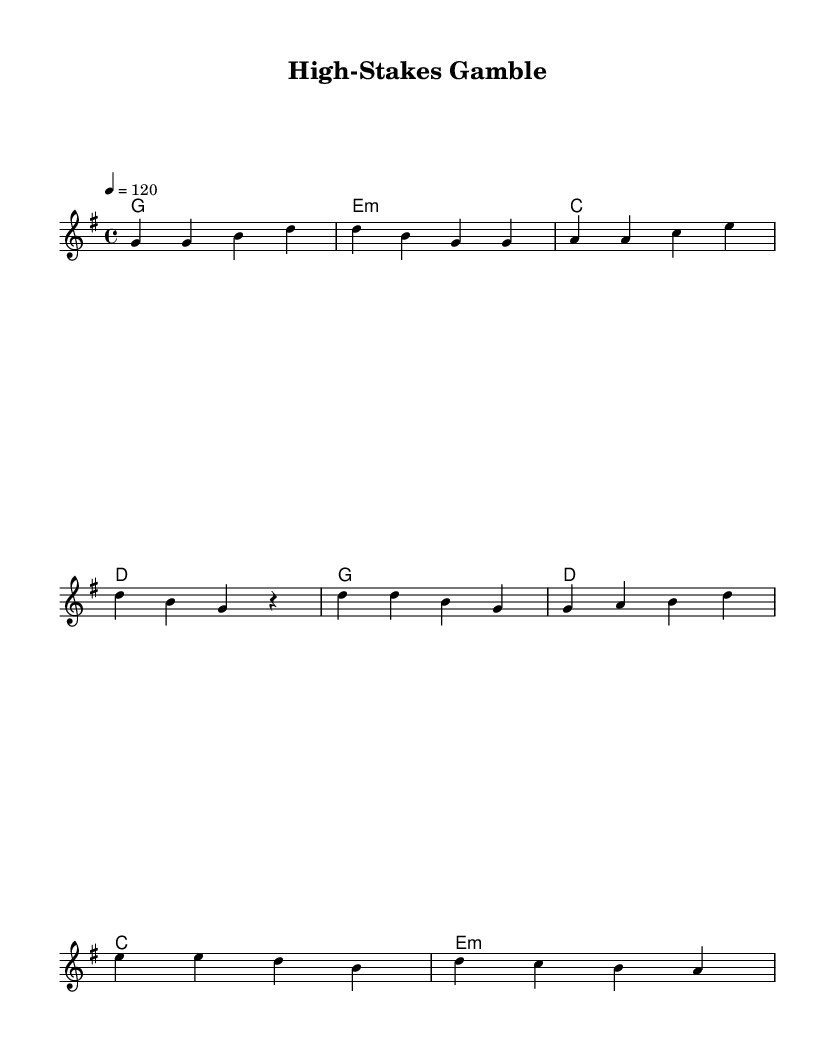What is the key signature of this music? The key signature shown in the score indicates G major, which has one sharp (F#).
Answer: G major What is the time signature of this music? The time signature written at the beginning is 4/4, meaning there are four beats in each measure and the quarter note gets one beat.
Answer: 4/4 What is the tempo of this song? The tempo marking indicates that the piece should be played at a speed of 120 beats per minute (bpm).
Answer: 120 How many verses are there in the song? The verse section consists of four lines of lyrics, indicating that there is one complete verse presented in this score.
Answer: One verse What chord follows the first melody note in the verse? The first melody note is G, and according to the chord changes, the first chord in the verse is G major.
Answer: G major Which lyrical theme does the chorus suggest? The chorus communicates a theme of risk and strategy in financial ventures, highlighted by phrases about high stakes and smart play.
Answer: Risk and strategy What emotional tone do the lyrics convey about the business deals? The lyrics suggest a tone of caution and tension due to the presence of rivals and the potential for loss, which reflects anxiety in high-stakes situations.
Answer: Caution and tension 